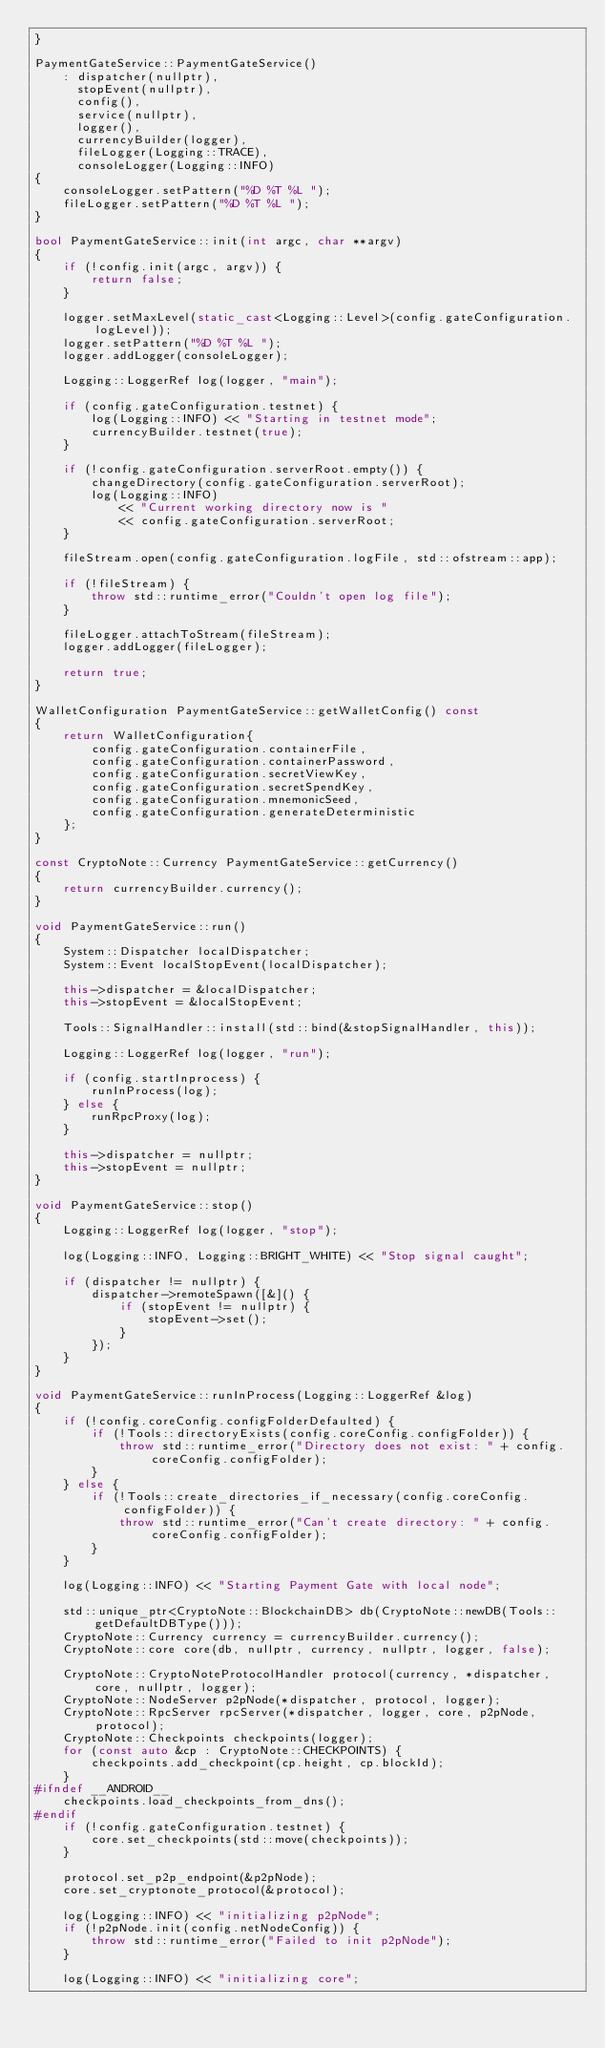<code> <loc_0><loc_0><loc_500><loc_500><_C++_>}

PaymentGateService::PaymentGateService()
    : dispatcher(nullptr),
      stopEvent(nullptr),
      config(),
      service(nullptr),
      logger(),
      currencyBuilder(logger),
      fileLogger(Logging::TRACE),
      consoleLogger(Logging::INFO)
{
    consoleLogger.setPattern("%D %T %L ");
    fileLogger.setPattern("%D %T %L ");
}

bool PaymentGateService::init(int argc, char **argv)
{
    if (!config.init(argc, argv)) {
        return false;
    }

    logger.setMaxLevel(static_cast<Logging::Level>(config.gateConfiguration.logLevel));
    logger.setPattern("%D %T %L ");
    logger.addLogger(consoleLogger);

    Logging::LoggerRef log(logger, "main");

    if (config.gateConfiguration.testnet) {
        log(Logging::INFO) << "Starting in testnet mode";
        currencyBuilder.testnet(true);
    }

    if (!config.gateConfiguration.serverRoot.empty()) {
        changeDirectory(config.gateConfiguration.serverRoot);
        log(Logging::INFO)
            << "Current working directory now is "
            << config.gateConfiguration.serverRoot;
    }

    fileStream.open(config.gateConfiguration.logFile, std::ofstream::app);

    if (!fileStream) {
        throw std::runtime_error("Couldn't open log file");
    }

    fileLogger.attachToStream(fileStream);
    logger.addLogger(fileLogger);

    return true;
}

WalletConfiguration PaymentGateService::getWalletConfig() const
{
    return WalletConfiguration{
        config.gateConfiguration.containerFile,
        config.gateConfiguration.containerPassword,
        config.gateConfiguration.secretViewKey,
        config.gateConfiguration.secretSpendKey,
        config.gateConfiguration.mnemonicSeed,
        config.gateConfiguration.generateDeterministic
    };
}

const CryptoNote::Currency PaymentGateService::getCurrency()
{
    return currencyBuilder.currency();
}

void PaymentGateService::run()
{
    System::Dispatcher localDispatcher;
    System::Event localStopEvent(localDispatcher);

    this->dispatcher = &localDispatcher;
    this->stopEvent = &localStopEvent;

    Tools::SignalHandler::install(std::bind(&stopSignalHandler, this));

    Logging::LoggerRef log(logger, "run");

    if (config.startInprocess) {
        runInProcess(log);
    } else {
        runRpcProxy(log);
    }

    this->dispatcher = nullptr;
    this->stopEvent = nullptr;
}

void PaymentGateService::stop()
{
    Logging::LoggerRef log(logger, "stop");

    log(Logging::INFO, Logging::BRIGHT_WHITE) << "Stop signal caught";

    if (dispatcher != nullptr) {
        dispatcher->remoteSpawn([&]() {
            if (stopEvent != nullptr) {
                stopEvent->set();
            }
        });
    }
}

void PaymentGateService::runInProcess(Logging::LoggerRef &log)
{
    if (!config.coreConfig.configFolderDefaulted) {
        if (!Tools::directoryExists(config.coreConfig.configFolder)) {
            throw std::runtime_error("Directory does not exist: " + config.coreConfig.configFolder);
        }
    } else {
        if (!Tools::create_directories_if_necessary(config.coreConfig.configFolder)) {
            throw std::runtime_error("Can't create directory: " + config.coreConfig.configFolder);
        }
    }

    log(Logging::INFO) << "Starting Payment Gate with local node";

    std::unique_ptr<CryptoNote::BlockchainDB> db(CryptoNote::newDB(Tools::getDefaultDBType()));
    CryptoNote::Currency currency = currencyBuilder.currency();
    CryptoNote::core core(db, nullptr, currency, nullptr, logger, false);

    CryptoNote::CryptoNoteProtocolHandler protocol(currency, *dispatcher, core, nullptr, logger);
    CryptoNote::NodeServer p2pNode(*dispatcher, protocol, logger);
    CryptoNote::RpcServer rpcServer(*dispatcher, logger, core, p2pNode, protocol);
    CryptoNote::Checkpoints checkpoints(logger);
    for (const auto &cp : CryptoNote::CHECKPOINTS) {
        checkpoints.add_checkpoint(cp.height, cp.blockId);
    }
#ifndef __ANDROID__
    checkpoints.load_checkpoints_from_dns();
#endif
    if (!config.gateConfiguration.testnet) {
        core.set_checkpoints(std::move(checkpoints));
    }

    protocol.set_p2p_endpoint(&p2pNode);
    core.set_cryptonote_protocol(&protocol);

    log(Logging::INFO) << "initializing p2pNode";
    if (!p2pNode.init(config.netNodeConfig)) {
        throw std::runtime_error("Failed to init p2pNode");
    }

    log(Logging::INFO) << "initializing core";</code> 